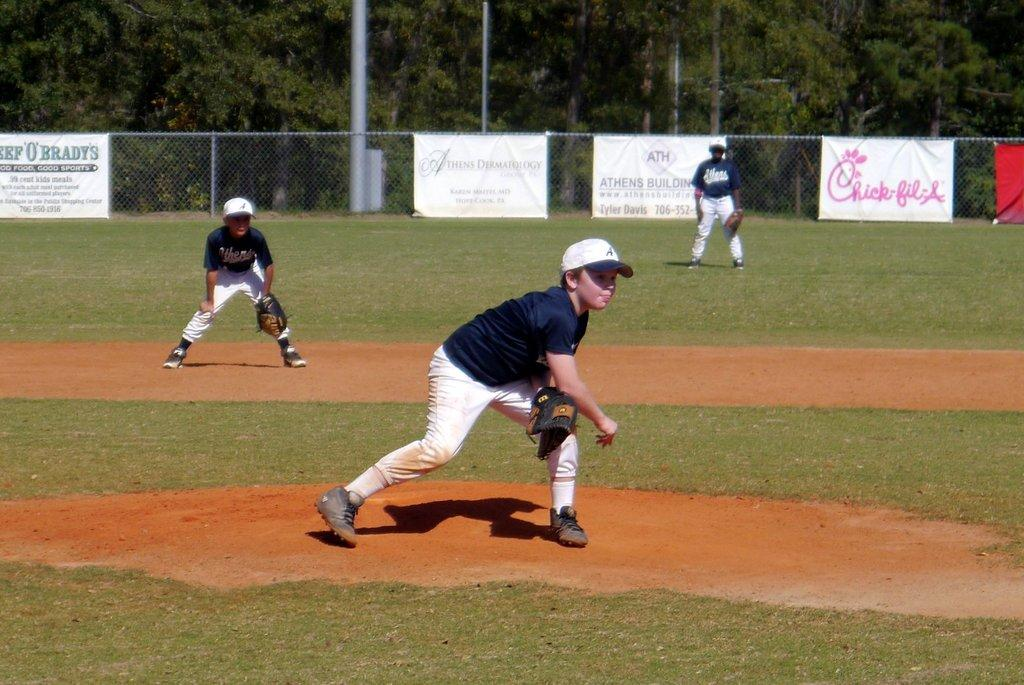<image>
Offer a succinct explanation of the picture presented. A little league baseball game on a field with advertising banners for Chick-fil-A and other businesses on the fences. 